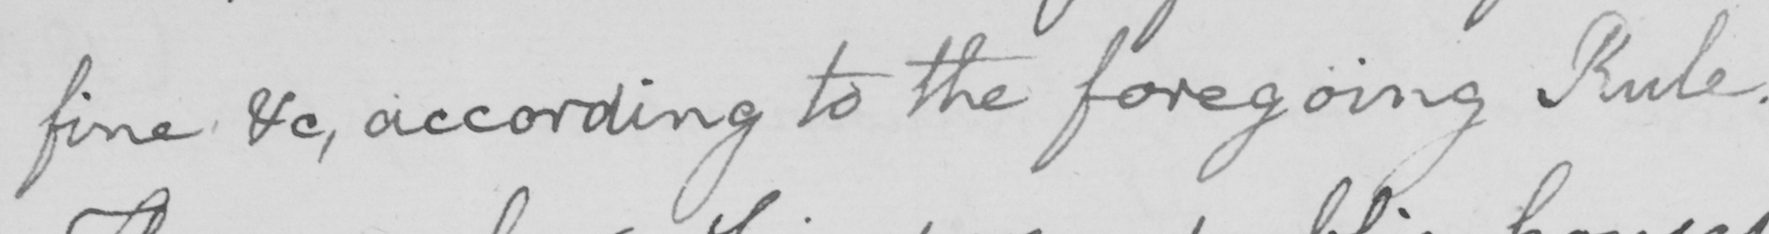What is written in this line of handwriting? fine &c , according to the foregoing Rule . 